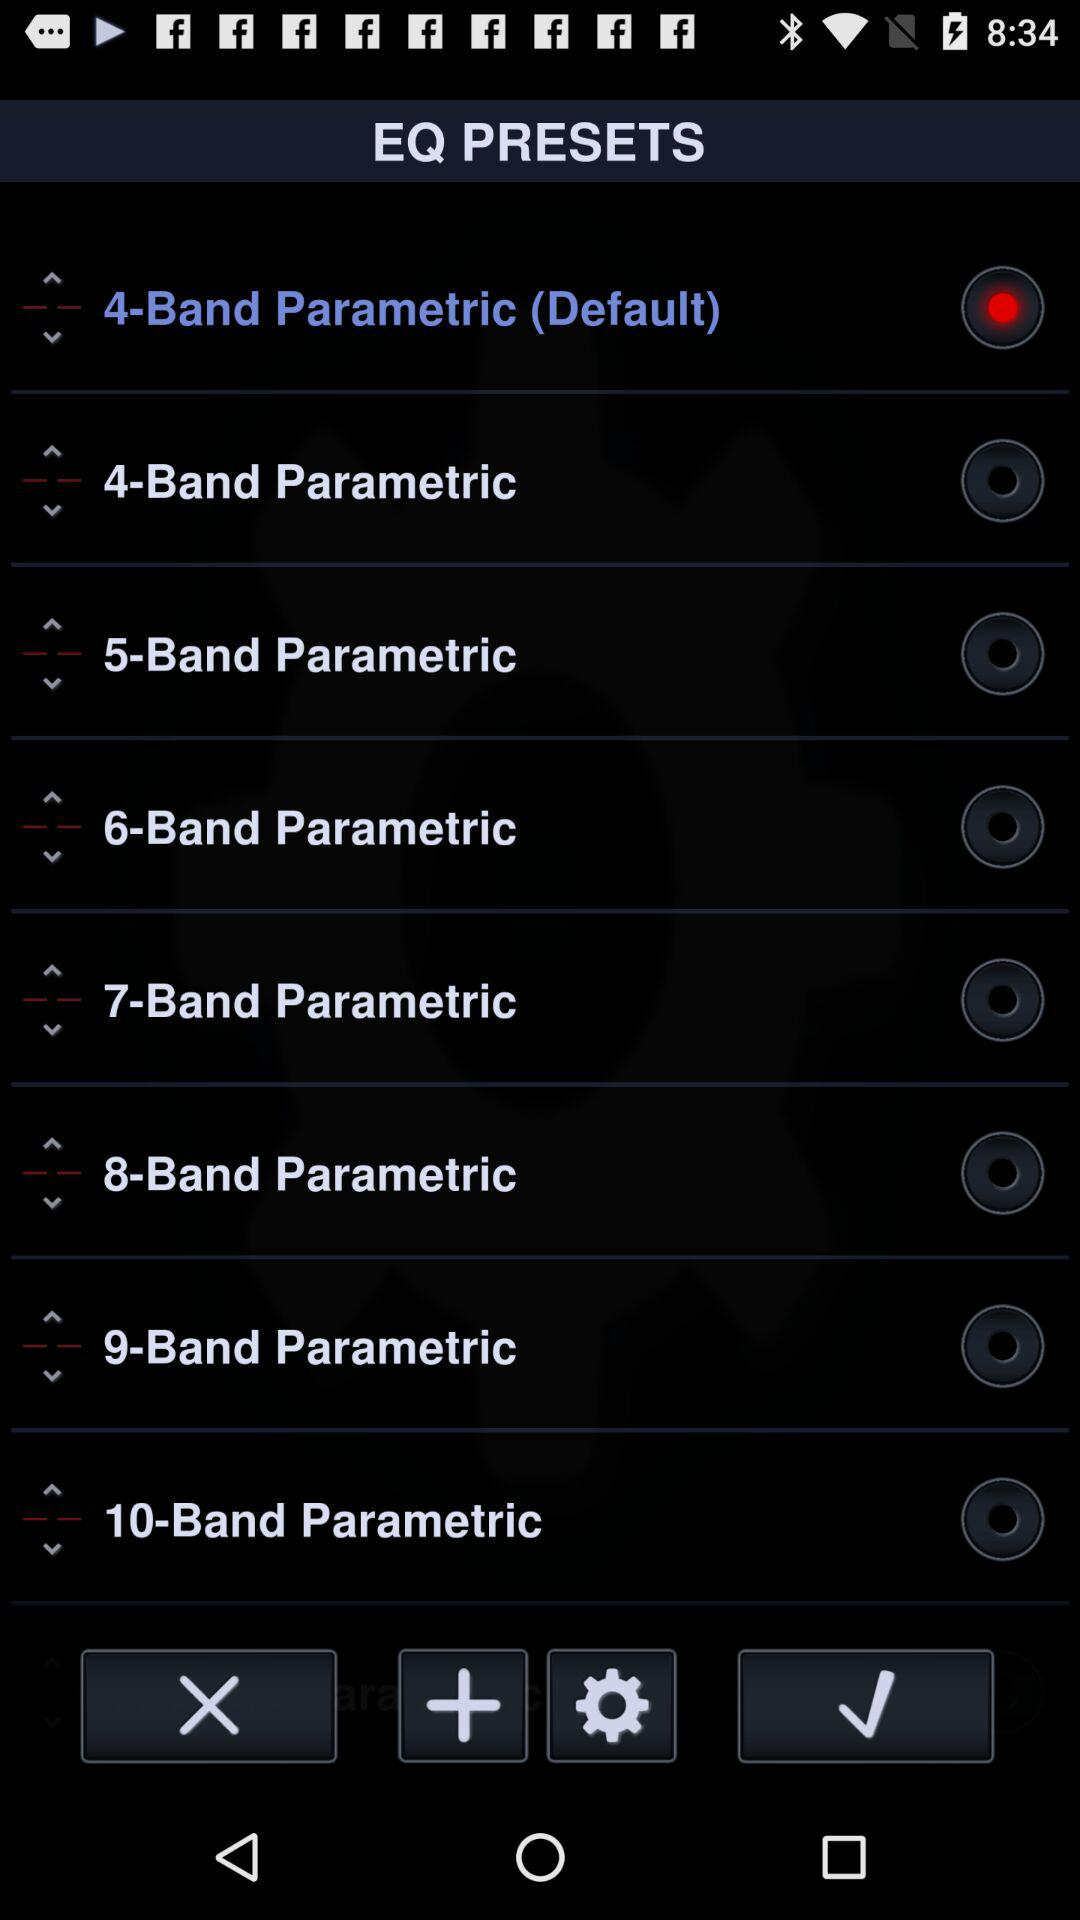How many EQ presets are there in total?
Answer the question using a single word or phrase. 10 